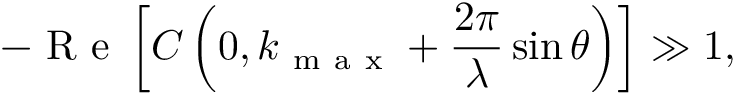Convert formula to latex. <formula><loc_0><loc_0><loc_500><loc_500>- R e \left [ C \left ( 0 , k _ { m a x } + \frac { 2 \pi } { \lambda } \sin \theta \right ) \right ] \gg 1 ,</formula> 